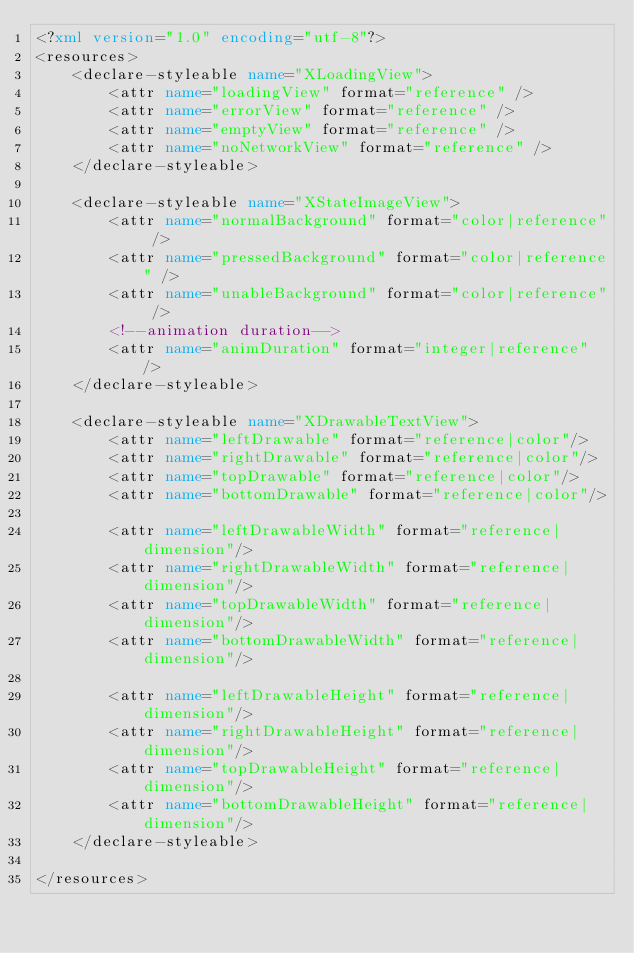Convert code to text. <code><loc_0><loc_0><loc_500><loc_500><_XML_><?xml version="1.0" encoding="utf-8"?>
<resources>
    <declare-styleable name="XLoadingView">
        <attr name="loadingView" format="reference" />
        <attr name="errorView" format="reference" />
        <attr name="emptyView" format="reference" />
        <attr name="noNetworkView" format="reference" />
    </declare-styleable>

    <declare-styleable name="XStateImageView">
        <attr name="normalBackground" format="color|reference" />
        <attr name="pressedBackground" format="color|reference" />
        <attr name="unableBackground" format="color|reference" />
        <!--animation duration-->
        <attr name="animDuration" format="integer|reference" />
    </declare-styleable>

    <declare-styleable name="XDrawableTextView">
        <attr name="leftDrawable" format="reference|color"/>
        <attr name="rightDrawable" format="reference|color"/>
        <attr name="topDrawable" format="reference|color"/>
        <attr name="bottomDrawable" format="reference|color"/>

        <attr name="leftDrawableWidth" format="reference|dimension"/>
        <attr name="rightDrawableWidth" format="reference|dimension"/>
        <attr name="topDrawableWidth" format="reference|dimension"/>
        <attr name="bottomDrawableWidth" format="reference|dimension"/>

        <attr name="leftDrawableHeight" format="reference|dimension"/>
        <attr name="rightDrawableHeight" format="reference|dimension"/>
        <attr name="topDrawableHeight" format="reference|dimension"/>
        <attr name="bottomDrawableHeight" format="reference|dimension"/>
    </declare-styleable>

</resources></code> 